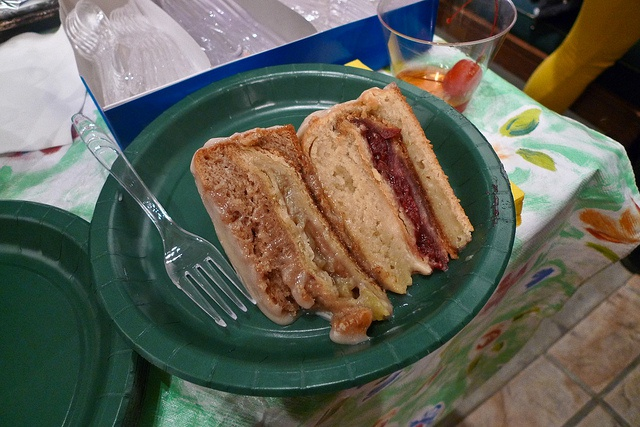Describe the objects in this image and their specific colors. I can see dining table in gray, black, teal, darkgray, and lightgray tones, cup in gray, navy, black, maroon, and darkgray tones, fork in gray, teal, darkgray, and black tones, people in gray, maroon, olive, and black tones, and spoon in gray, darkgray, and lightgray tones in this image. 